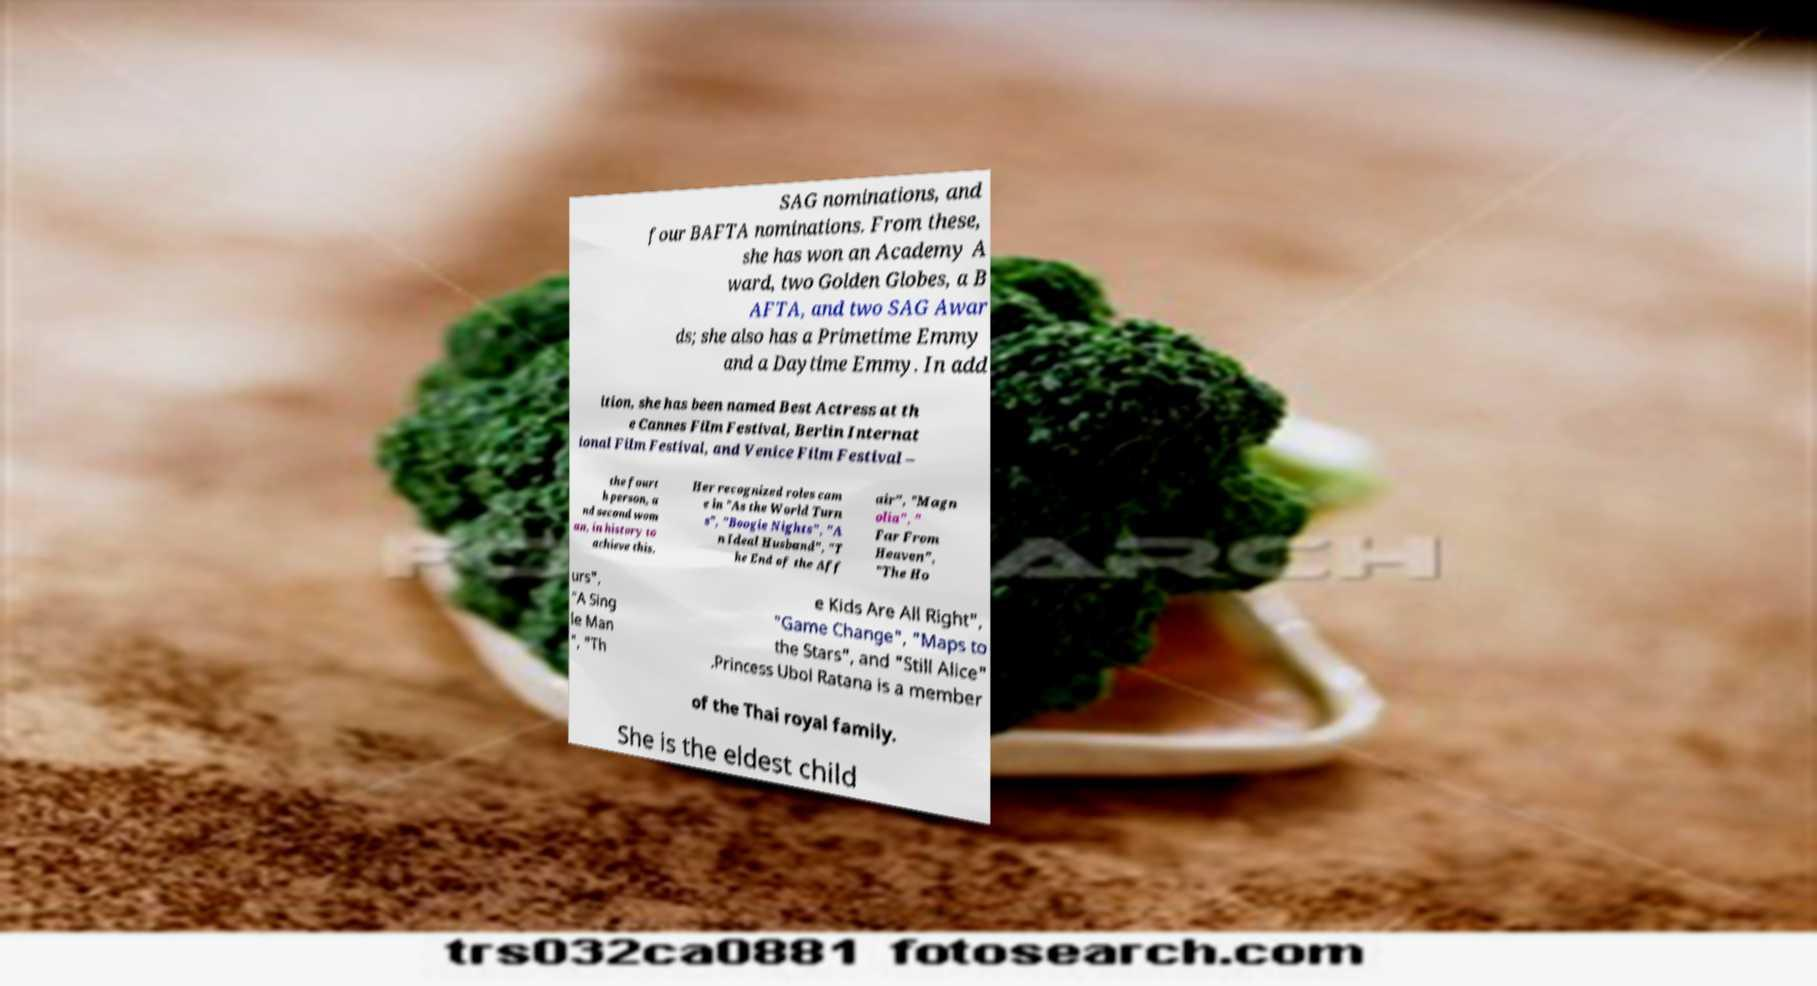I need the written content from this picture converted into text. Can you do that? SAG nominations, and four BAFTA nominations. From these, she has won an Academy A ward, two Golden Globes, a B AFTA, and two SAG Awar ds; she also has a Primetime Emmy and a Daytime Emmy. In add ition, she has been named Best Actress at th e Cannes Film Festival, Berlin Internat ional Film Festival, and Venice Film Festival – the fourt h person, a nd second wom an, in history to achieve this. Her recognized roles cam e in "As the World Turn s", "Boogie Nights", "A n Ideal Husband", "T he End of the Aff air", "Magn olia", " Far From Heaven", "The Ho urs", "A Sing le Man ", "Th e Kids Are All Right", "Game Change", "Maps to the Stars", and "Still Alice" .Princess Ubol Ratana is a member of the Thai royal family. She is the eldest child 